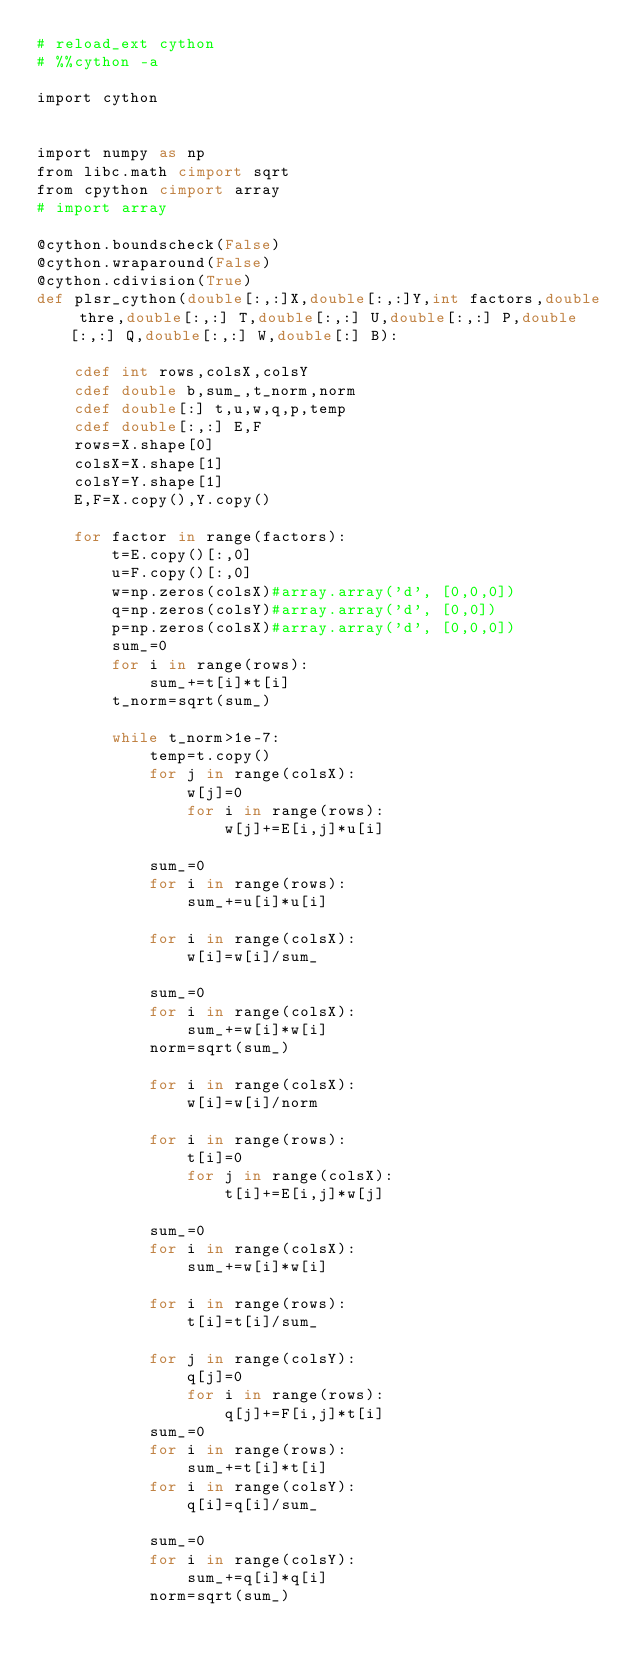Convert code to text. <code><loc_0><loc_0><loc_500><loc_500><_Cython_># reload_ext cython
# %%cython -a

import cython


import numpy as np
from libc.math cimport sqrt
from cpython cimport array
# import array

@cython.boundscheck(False)
@cython.wraparound(False)
@cython.cdivision(True)
def plsr_cython(double[:,:]X,double[:,:]Y,int factors,double thre,double[:,:] T,double[:,:] U,double[:,:] P,double[:,:] Q,double[:,:] W,double[:] B):
    
    cdef int rows,colsX,colsY
    cdef double b,sum_,t_norm,norm
    cdef double[:] t,u,w,q,p,temp
    cdef double[:,:] E,F
    rows=X.shape[0]
    colsX=X.shape[1]
    colsY=Y.shape[1]
    E,F=X.copy(),Y.copy()
    
    for factor in range(factors):
        t=E.copy()[:,0]
        u=F.copy()[:,0]
        w=np.zeros(colsX)#array.array('d', [0,0,0])
        q=np.zeros(colsY)#array.array('d', [0,0])
        p=np.zeros(colsX)#array.array('d', [0,0,0])
        sum_=0
        for i in range(rows):
            sum_+=t[i]*t[i]
        t_norm=sqrt(sum_)
        
        while t_norm>1e-7:      
            temp=t.copy()
            for j in range(colsX):
                w[j]=0
                for i in range(rows):
                    w[j]+=E[i,j]*u[i]

            sum_=0
            for i in range(rows):
                sum_+=u[i]*u[i]

            for i in range(colsX):
                w[i]=w[i]/sum_

            sum_=0
            for i in range(colsX):
                sum_+=w[i]*w[i]
            norm=sqrt(sum_)
            
            for i in range(colsX):
                w[i]=w[i]/norm

            for i in range(rows):
                t[i]=0
                for j in range(colsX):
                    t[i]+=E[i,j]*w[j]

            sum_=0
            for i in range(colsX):
                sum_+=w[i]*w[i]  

            for i in range(rows):
                t[i]=t[i]/sum_
 
            for j in range(colsY):
                q[j]=0
                for i in range(rows):
                    q[j]+=F[i,j]*t[i]
            sum_=0
            for i in range(rows):
                sum_+=t[i]*t[i]  
            for i in range(colsY):
                q[i]=q[i]/sum_
            
            sum_=0
            for i in range(colsY):
                sum_+=q[i]*q[i]
            norm=sqrt(sum_)
</code> 